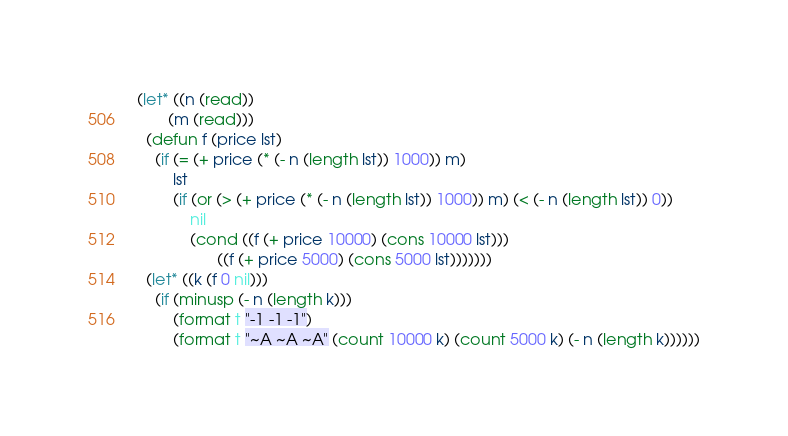Convert code to text. <code><loc_0><loc_0><loc_500><loc_500><_Lisp_>(let* ((n (read))
       (m (read)))
  (defun f (price lst)
    (if (= (+ price (* (- n (length lst)) 1000)) m)
        lst
        (if (or (> (+ price (* (- n (length lst)) 1000)) m) (< (- n (length lst)) 0))
            nil
            (cond ((f (+ price 10000) (cons 10000 lst)))
                  ((f (+ price 5000) (cons 5000 lst)))))))
  (let* ((k (f 0 nil)))
    (if (minusp (- n (length k)))
        (format t "-1 -1 -1")
        (format t "~A ~A ~A" (count 10000 k) (count 5000 k) (- n (length k))))))</code> 